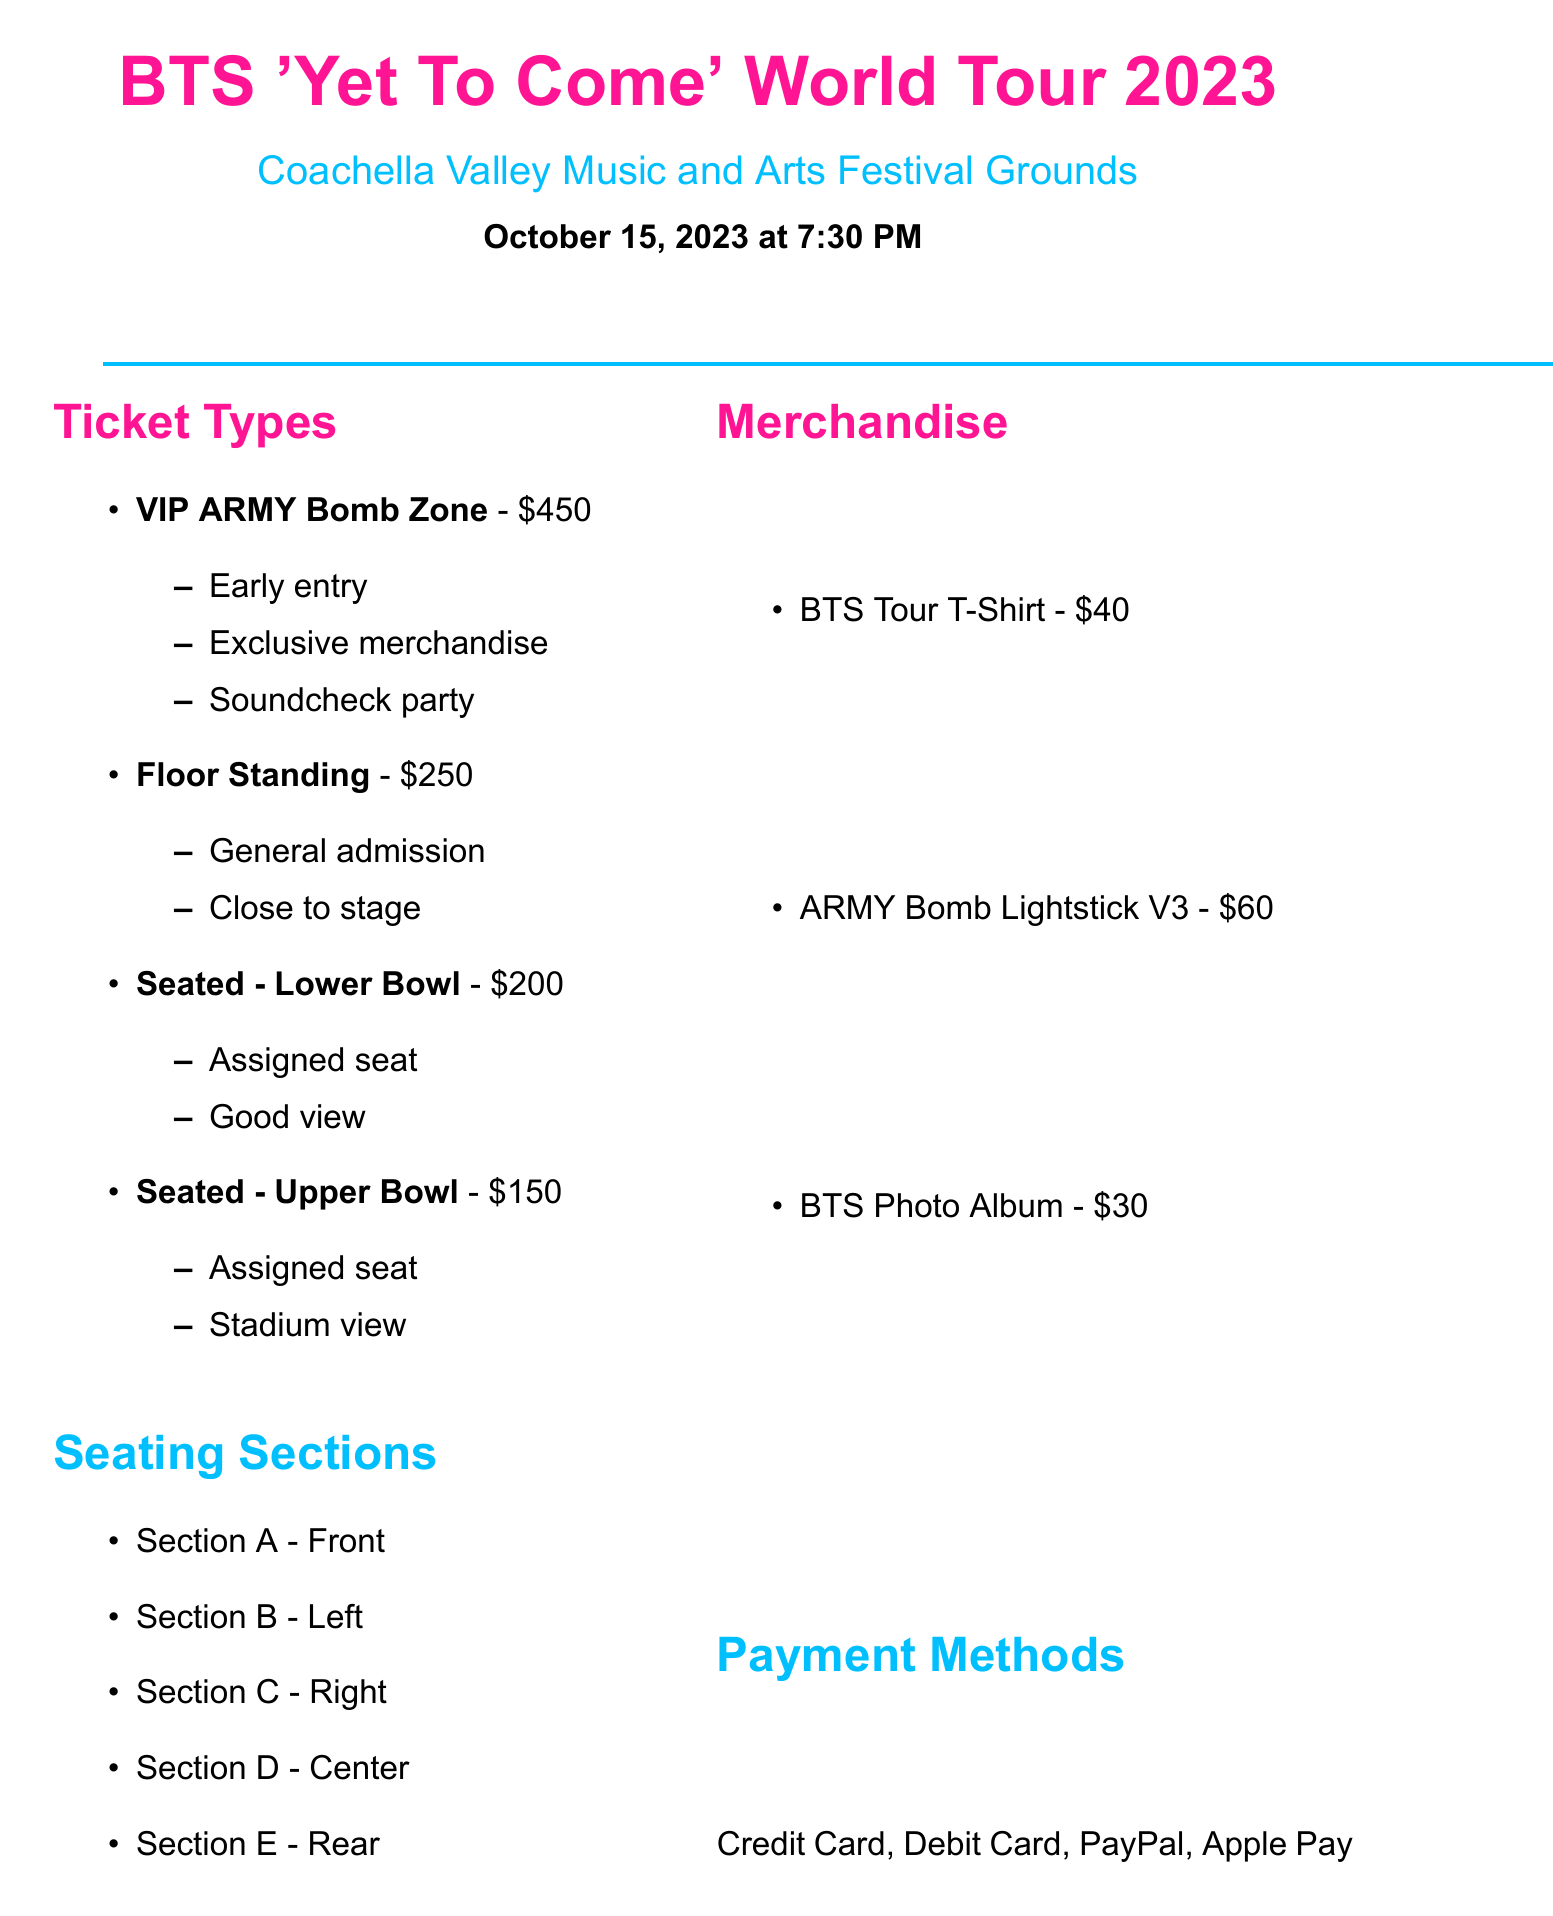What is the date of the concert? The date of the concert is clearly stated in the document as October 15, 2023.
Answer: October 15, 2023 What is the venue for the BTS concert? The venue is mentioned in the document as Coachella Valley Music and Arts Festival Grounds.
Answer: Coachella Valley Music and Arts Festival Grounds How much is the VIP ARMY Bomb Zone ticket? The document specifies the price for the VIP ARMY Bomb Zone ticket as 450.
Answer: 450 What are the benefits of the Floor Standing ticket? The benefits listed for the Floor Standing ticket in the document include general admission and close to stage.
Answer: General admission, close to stage Which hotels are listed nearby? The document includes a section listing nearby hotels, which are La Quinta Resort & Club, Hyatt Regency Indian Wells Resort & Spa, and JW Marriott Desert Springs Resort & Spa.
Answer: La Quinta Resort & Club, Hyatt Regency Indian Wells Resort & Spa, JW Marriott Desert Springs Resort & Spa What is the price of the ARMY Bomb Lightstick V3? The document mentions the price of the ARMY Bomb Lightstick V3 as 60.
Answer: 60 What special requirement is mentioned for seating? The document lists wheelchair accessible seating as one of the special requirements.
Answer: Wheelchair accessible seating What payment methods are available? The document specifies that available payment methods include credit card, debit card, PayPal, and Apple Pay.
Answer: Credit Card, Debit Card, PayPal, Apple Pay What is one local attraction mentioned? The document lists Joshua Tree National Park as one of the local attractions.
Answer: Joshua Tree National Park What is advised regarding professional cameras? The document states that no professional cameras or recording devices are allowed.
Answer: No professional cameras or recording devices allowed 